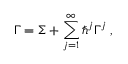<formula> <loc_0><loc_0><loc_500><loc_500>\Gamma = \Sigma + \sum _ { j = 1 } ^ { \infty } \hbar { ^ } { j } \Gamma ^ { j } \, ,</formula> 